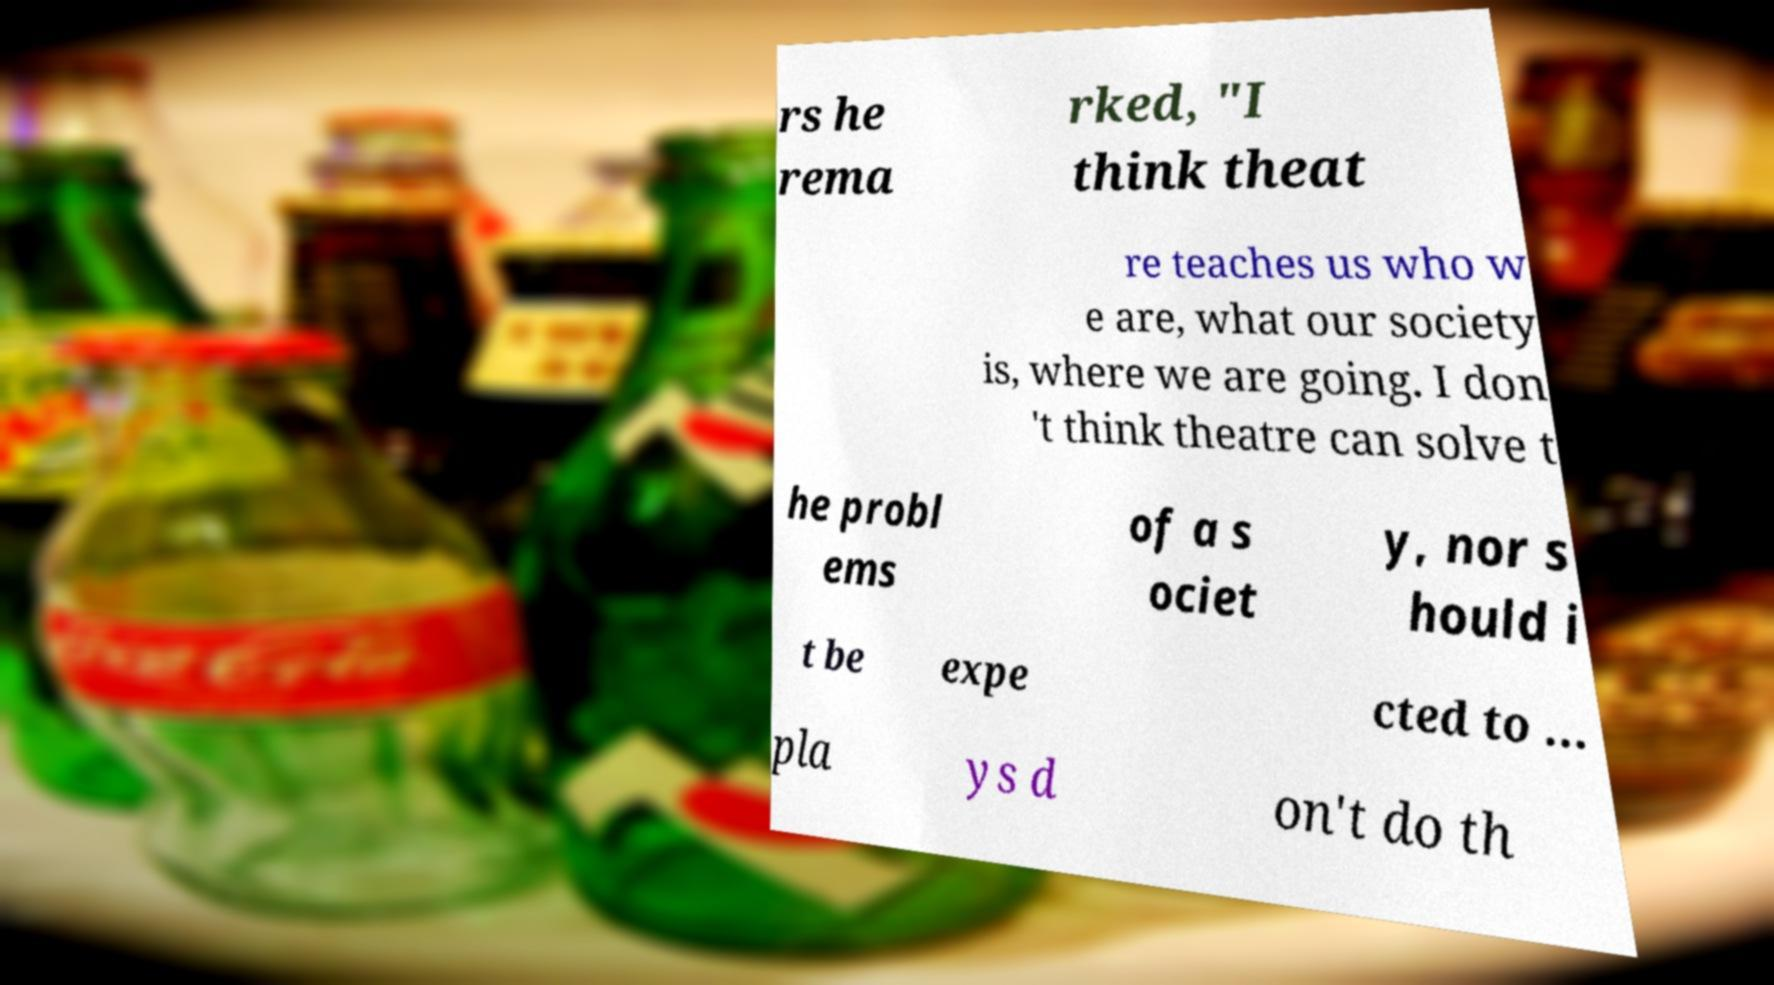Could you assist in decoding the text presented in this image and type it out clearly? rs he rema rked, "I think theat re teaches us who w e are, what our society is, where we are going. I don 't think theatre can solve t he probl ems of a s ociet y, nor s hould i t be expe cted to ... pla ys d on't do th 